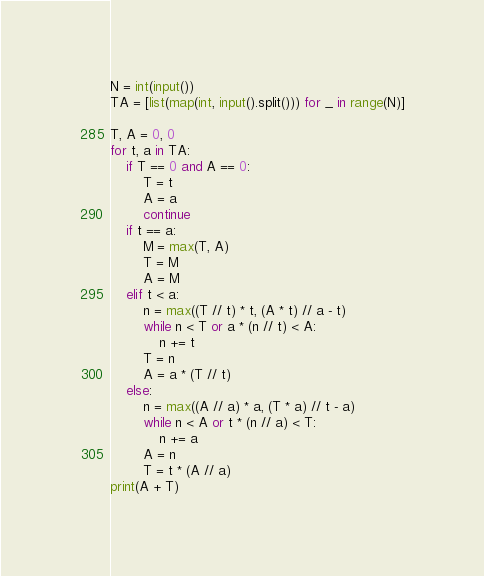<code> <loc_0><loc_0><loc_500><loc_500><_Python_>N = int(input())
TA = [list(map(int, input().split())) for _ in range(N)]

T, A = 0, 0
for t, a in TA:
    if T == 0 and A == 0:
        T = t
        A = a
        continue
    if t == a:
        M = max(T, A)
        T = M
        A = M
    elif t < a:
        n = max((T // t) * t, (A * t) // a - t)
        while n < T or a * (n // t) < A:
            n += t
        T = n
        A = a * (T // t)
    else:
        n = max((A // a) * a, (T * a) // t - a)
        while n < A or t * (n // a) < T:
            n += a
        A = n
        T = t * (A // a)
print(A + T)</code> 